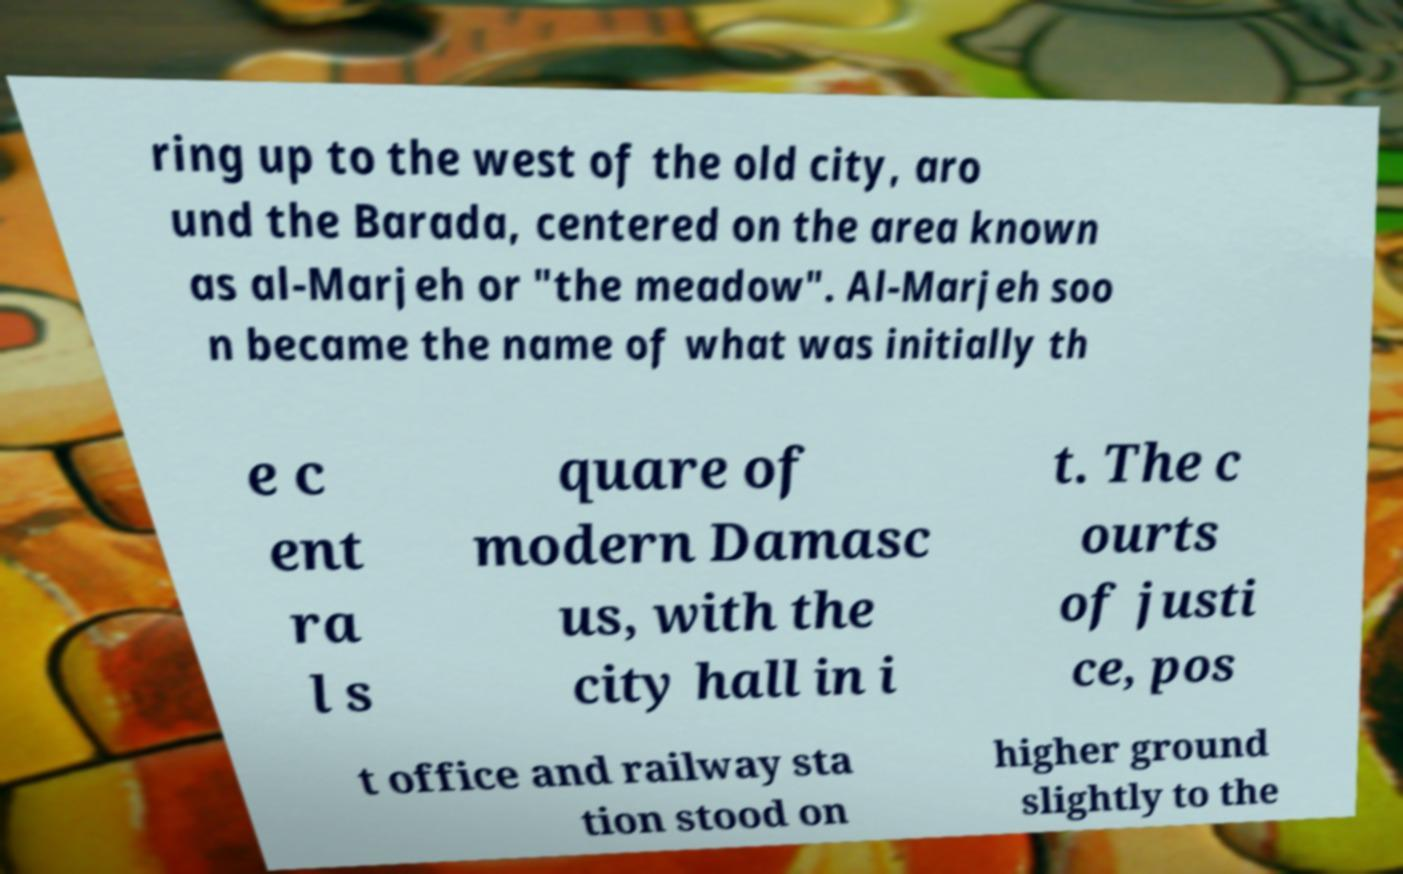There's text embedded in this image that I need extracted. Can you transcribe it verbatim? ring up to the west of the old city, aro und the Barada, centered on the area known as al-Marjeh or "the meadow". Al-Marjeh soo n became the name of what was initially th e c ent ra l s quare of modern Damasc us, with the city hall in i t. The c ourts of justi ce, pos t office and railway sta tion stood on higher ground slightly to the 